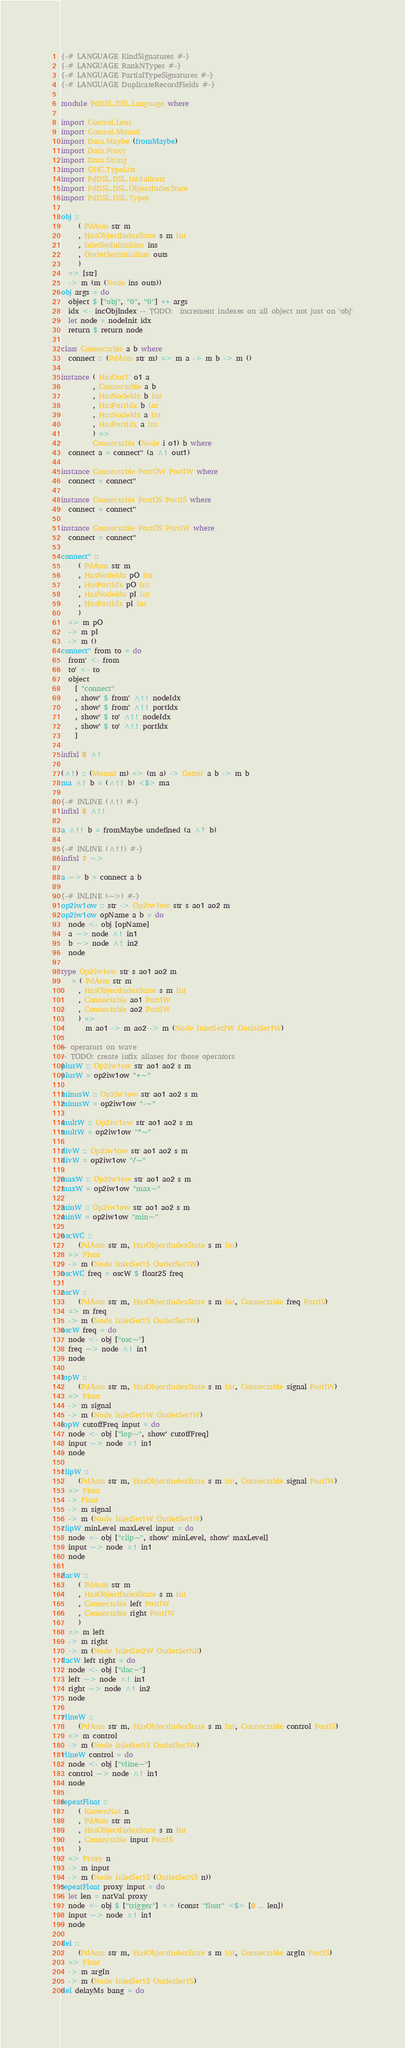Convert code to text. <code><loc_0><loc_0><loc_500><loc_500><_Haskell_>{-# LANGUAGE KindSignatures #-}
{-# LANGUAGE RankNTypes #-}
{-# LANGUAGE PartialTypeSignatures #-}
{-# LANGUAGE DuplicateRecordFields #-}

module PdDSL.DSL.Language where

import Control.Lens
import Control.Monad
import Data.Maybe (fromMaybe)
import Data.Proxy
import Data.String
import GHC.TypeLits
import PdDSL.DSL.Initializers
import PdDSL.DSL.ObjectIndexState
import PdDSL.DSL.Types

obj ::
     ( PdAsm str m
     , HasObjectIndexState s m Int
     , InletSetInitializer ins
     , OutletSetInitializer outs
     )
  => [str]
  -> m (m (Node ins outs))
obj args = do
  object $ ["obj", "0", "0"] ++ args
  idx <- incObjIndex -- TODO:  increment indexes on all object not just on 'obj'
  let node = nodeInit idx
  return $ return node

class Connectable a b where
  connect :: (PdAsm str m) => m a -> m b -> m ()

instance ( HasOut1' o1 a
         , Connectable a b
         , HasNodeIdx b Int
         , HasPortIdx b Int
         , HasNodeIdx a Int
         , HasPortIdx a Int
         ) =>
         Connectable (Node i o1) b where
  connect a = connect'' (a ^! out1)

instance Connectable PortOW PortIW where
  connect = connect''

instance Connectable PortOS PortIS where
  connect = connect''

instance Connectable PortOS PortIW where
  connect = connect''

connect'' ::
     ( PdAsm str m
     , HasNodeIdx pO Int
     , HasPortIdx pO Int
     , HasNodeIdx pI Int
     , HasPortIdx pI Int
     )
  => m pO
  -> m pI
  -> m ()
connect'' from to = do
  from' <- from
  to' <- to
  object
    [ "connect"
    , show' $ from' ^!! nodeIdx
    , show' $ from' ^!! portIdx
    , show' $ to' ^!! nodeIdx
    , show' $ to' ^!! portIdx
    ]

infixl 8 ^!

(^!) :: (Monad m) => (m a) -> Getter a b -> m b
ma ^! b = (^!! b) <$> ma

{-# INLINE (^!) #-}
infixl 8 ^!!

a ^!! b = fromMaybe undefined (a ^? b)

{-# INLINE (^!!) #-}
infixl 7 ~>

a ~> b = connect a b

{-# INLINE (~>) #-}
op2iw1ow :: str -> Op2iw1ow str s ao1 ao2 m
op2iw1ow opName a b = do
  node <- obj [opName]
  a ~> node ^! in1
  b ~> node ^! in2
  node

type Op2iw1ow str s ao1 ao2 m
   = ( PdAsm str m
     , HasObjectIndexState s m Int
     , Connectable ao1 PortIW
     , Connectable ao2 PortIW
     ) =>
       m ao1 -> m ao2 -> m (Node InletSet2W OutletSet1W)

-- operators on wave
-- TODO: create infix aliases for those operators
plusW :: Op2iw1ow str ao1 ao2 s m
plusW = op2iw1ow "+~"

minusW :: Op2iw1ow str ao1 ao2 s m
minusW = op2iw1ow "-~"

multW :: Op2iw1ow str ao1 ao2 s m
multW = op2iw1ow "*~"

divW :: Op2iw1ow str ao1 ao2 s m
divW = op2iw1ow "/~"

maxW :: Op2iw1ow str ao1 ao2 s m
maxW = op2iw1ow "max~"

minW :: Op2iw1ow str ao1 ao2 s m
minW = op2iw1ow "min~"

oscWC ::
     (PdAsm str m, HasObjectIndexState s m Int)
  => Float
  -> m (Node InletSet1S OutletSet1W)
oscWC freq = oscW $ float2S freq

oscW ::
     (PdAsm str m, HasObjectIndexState s m Int, Connectable freq PortIS)
  => m freq
  -> m (Node InletSet1S OutletSet1W)
oscW freq = do
  node <- obj ["osc~"]
  freq ~> node ^! in1
  node

lopW ::
     (PdAsm str m, HasObjectIndexState s m Int, Connectable signal PortIW)
  => Float
  -> m signal
  -> m (Node InletSet1W OutletSet1W)
lopW cutoffFreq input = do
  node <- obj ["lop~", show' cutoffFreq]
  input ~> node ^! in1
  node

clipW ::
     (PdAsm str m, HasObjectIndexState s m Int, Connectable signal PortIW)
  => Float
  -> Float
  -> m signal
  -> m (Node InletSet1W OutletSet1W)
clipW minLevel maxLevel input = do
  node <- obj ["clip~", show' minLevel, show' maxLevel]
  input ~> node ^! in1
  node

dacW ::
     ( PdAsm str m
     , HasObjectIndexState s m Int
     , Connectable left PortIW
     , Connectable right PortIW
     )
  => m left
  -> m right
  -> m (Node InletSet2W OutletSetNil)
dacW left right = do
  node <- obj ["dac~"]
  left ~> node ^! in1
  right ~> node ^! in2
  node

vlineW ::
     (PdAsm str m, HasObjectIndexState s m Int, Connectable control PortIS)
  => m control
  -> m (Node InletSet1S OutletSet1W)
vlineW control = do
  node <- obj ["vline~"]
  control ~> node ^! in1
  node

repeatFloat ::
     ( KnownNat n
     , PdAsm str m
     , HasObjectIndexState s m Int
     , Connectable input PortIS
     )
  => Proxy n
  -> m input
  -> m (Node InletSet1S (OutletSetNS n))
repeatFloat proxy input = do
  let len = natVal proxy
  node <- obj $ ["trigger"] <> (const "float" <$> [0 .. len])
  input ~> node ^! in1
  node

del ::
     (PdAsm str m, HasObjectIndexState s m Int, Connectable argIn PortIS)
  => Float
  -> m argIn
  -> m (Node InletSet1S OutletSet1S)
del delayMs bang = do</code> 